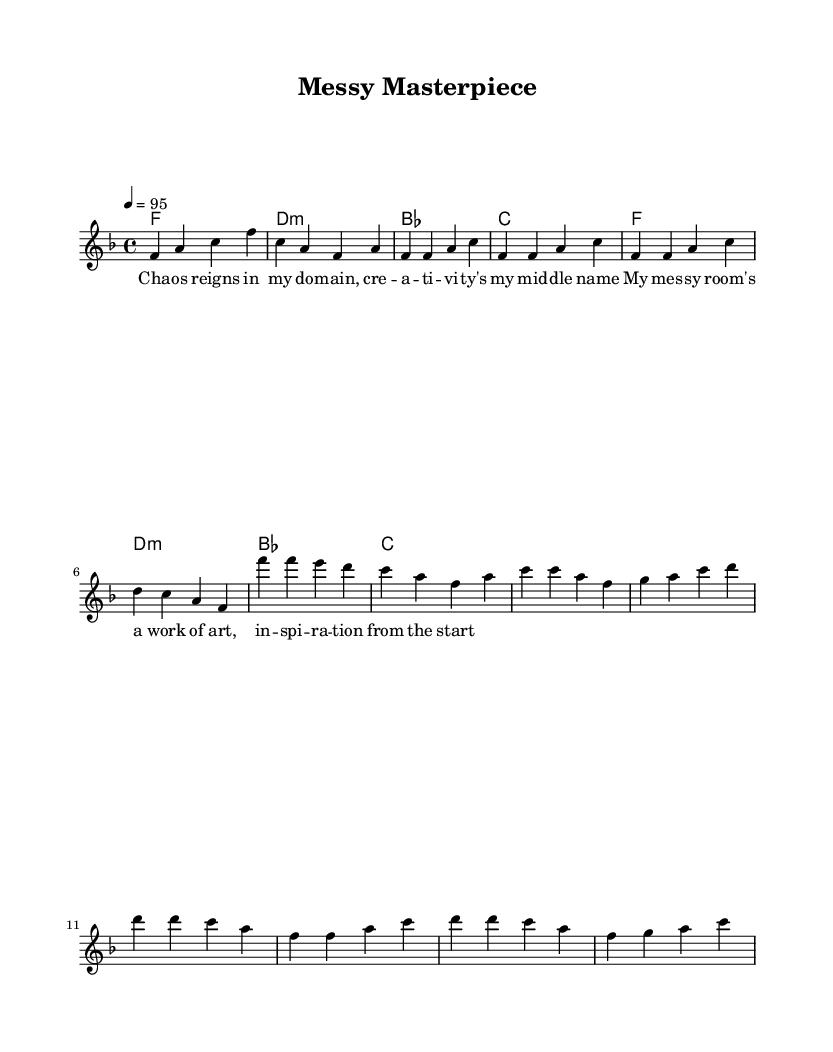What is the key signature of this music? The key signature is F major, which has one flat (B flat). You can identify the key signature from the beginning of the staff where the flats appear.
Answer: F major What is the time signature of this piece? The time signature is four four, indicated as 4/4 at the beginning of the piece. This means there are four beats in each measure, and the quarter note gets one beat.
Answer: Four four What is the tempo marking in this piece? The tempo marking is 95 beats per minute, shown as "4 = 95" which tells the performer to play 95 quarter-note beats in a minute.
Answer: 95 How many measures are in the melody? The melody contains a total of 8 measures, counting the intro, verse, chorus, and bridge sections as indicated by the bars.
Answer: 8 What word describes the theme of the lyrics? The theme of the lyrics is chaos, which is evident in the lyrics celebrating the messiness and creativity of a room.
Answer: Chaos What type of music is this score representing? This score represents Hip Hop music, as indicated by the upbeat rhythm and the celebratory lyrics related to personal creativity.
Answer: Hip Hop How many chords are played during the measures? There are 4 different chords indicated in the score, which are played in 2 groups of two measures each.
Answer: 4 